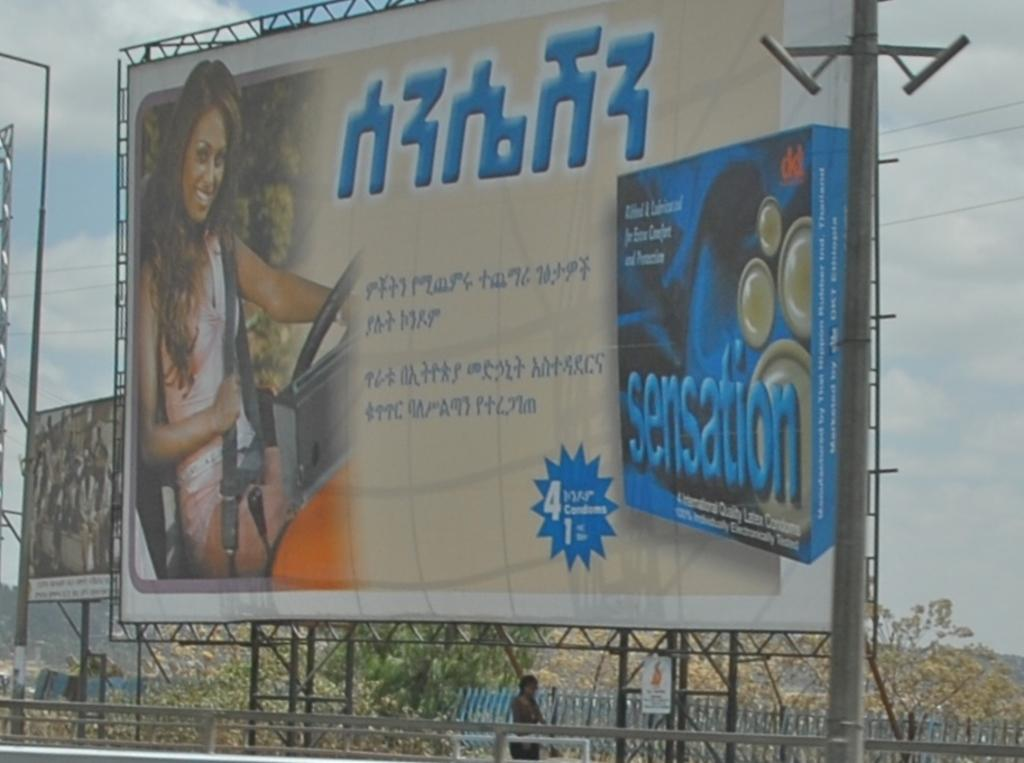<image>
Share a concise interpretation of the image provided. A billboard showing a woman driving on the left side and a blue box on the right with the "sensation" on it. 